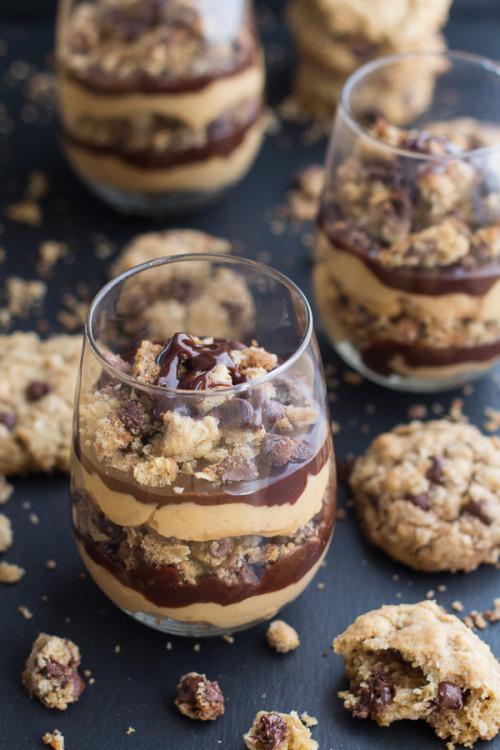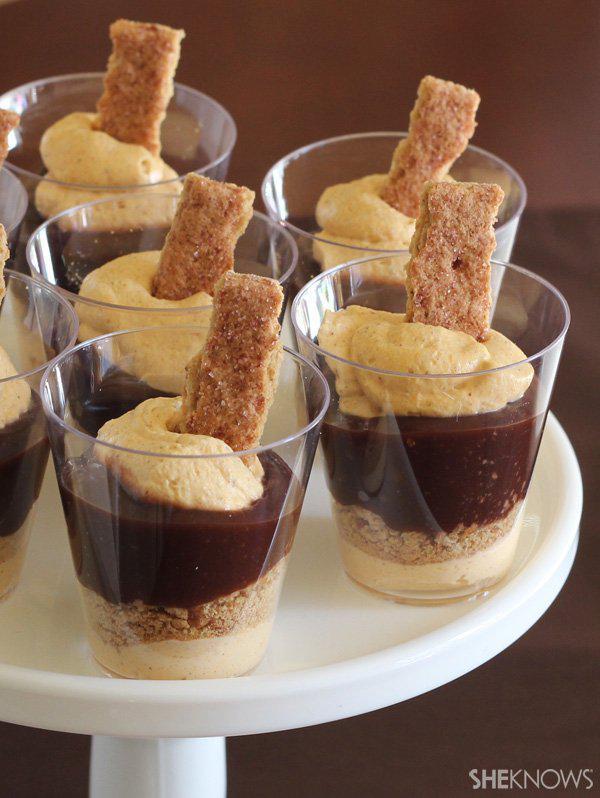The first image is the image on the left, the second image is the image on the right. Evaluate the accuracy of this statement regarding the images: "An image shows a cream-layered dessert in a clear footed glass.". Is it true? Answer yes or no. No. The first image is the image on the left, the second image is the image on the right. For the images displayed, is the sentence "There are three silver spoons next to the desserts in one of the images." factually correct? Answer yes or no. No. 